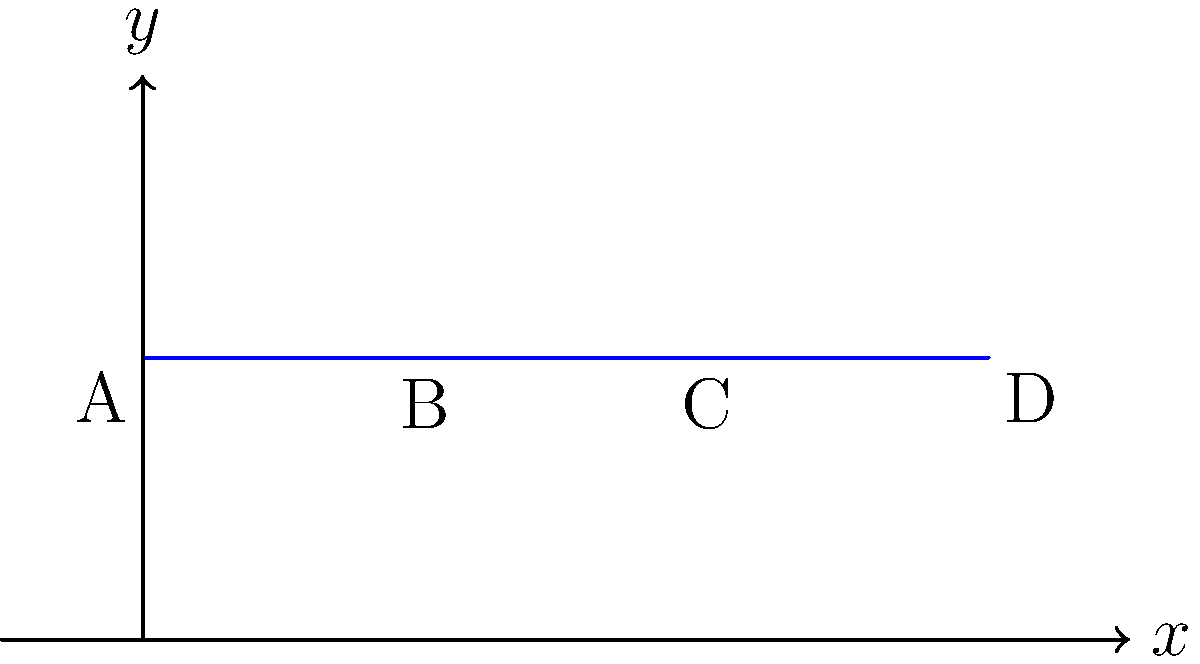In the Poincaré half-plane model of hyperbolic geometry, consider a polygon ABCD with vertices A(0,1), B(1,1), C(2,1), and D(3,1). Calculate the area of this polygon in hyperbolic geometry. (Hint: In the Poincaré half-plane model, the hyperbolic area element is given by $dA = \frac{dxdy}{y^2}$) To solve this problem, we'll follow these steps:

1) In the Poincaré half-plane model, the hyperbolic area element is given by:

   $dA = \frac{dxdy}{y^2}$

2) Our polygon ABCD is a straight line segment in the Euclidean sense, but it's a geodesic in hyperbolic geometry. All points on this line have y-coordinate 1.

3) To find the area, we need to integrate the area element along the line segment:

   $A = \int_{0}^{3} \frac{dx}{1^2} = \int_{0}^{3} dx = 3$

4) This integration is straightforward because y is constant (y=1) along the entire line segment, and the x-coordinate ranges from 0 to 3.

5) Therefore, the hyperbolic area of the polygon ABCD is 3 square units in the Poincaré half-plane model.

This problem illustrates how even simple shapes in Euclidean geometry can have interesting properties in hyperbolic geometry. In Euclidean geometry, a line segment would have zero area, but in hyperbolic geometry, it has a non-zero area.
Answer: 3 square units 